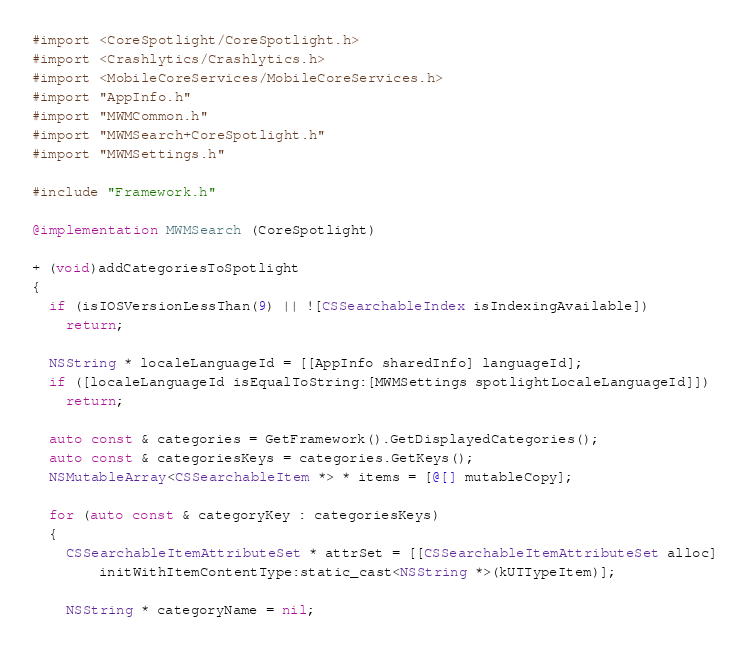Convert code to text. <code><loc_0><loc_0><loc_500><loc_500><_ObjectiveC_>#import <CoreSpotlight/CoreSpotlight.h>
#import <Crashlytics/Crashlytics.h>
#import <MobileCoreServices/MobileCoreServices.h>
#import "AppInfo.h"
#import "MWMCommon.h"
#import "MWMSearch+CoreSpotlight.h"
#import "MWMSettings.h"

#include "Framework.h"

@implementation MWMSearch (CoreSpotlight)

+ (void)addCategoriesToSpotlight
{
  if (isIOSVersionLessThan(9) || ![CSSearchableIndex isIndexingAvailable])
    return;

  NSString * localeLanguageId = [[AppInfo sharedInfo] languageId];
  if ([localeLanguageId isEqualToString:[MWMSettings spotlightLocaleLanguageId]])
    return;

  auto const & categories = GetFramework().GetDisplayedCategories();
  auto const & categoriesKeys = categories.GetKeys();
  NSMutableArray<CSSearchableItem *> * items = [@[] mutableCopy];

  for (auto const & categoryKey : categoriesKeys)
  {
    CSSearchableItemAttributeSet * attrSet = [[CSSearchableItemAttributeSet alloc]
        initWithItemContentType:static_cast<NSString *>(kUTTypeItem)];

    NSString * categoryName = nil;</code> 